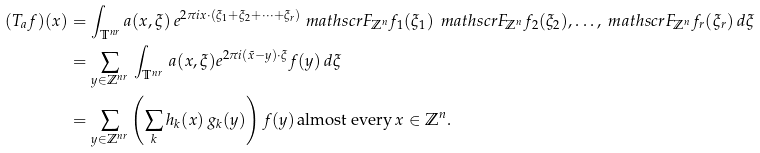Convert formula to latex. <formula><loc_0><loc_0><loc_500><loc_500>( T _ { a } f ) ( x ) & = \int _ { \mathbb { T } ^ { n r } } a ( x , \xi ) \, e ^ { 2 \pi i x \cdot ( \xi _ { 1 } + \xi _ { 2 } + \cdots + \xi _ { r } ) } \ m a t h s c r { F } _ { \mathbb { Z } ^ { n } } f _ { 1 } ( \xi _ { 1 } ) \, \ m a t h s c r { F } _ { \mathbb { Z } ^ { n } } f _ { 2 } ( \xi _ { 2 } ) , \dots , \ m a t h s c r { F } _ { \mathbb { Z } ^ { n } } f _ { r } ( \xi _ { r } ) \, d \xi \\ & = \sum _ { y \in \mathbb { Z } ^ { n r } } \, \int _ { \mathbb { T } ^ { n r } } \, a ( x , \xi ) e ^ { 2 \pi i ( \tilde { x } - y ) \cdot \xi } f ( y ) \, d \xi \\ & = \sum _ { y \in \mathbb { Z } ^ { n r } } \left ( \sum _ { k } h _ { k } ( x ) \, g _ { k } ( y ) \right ) f ( y ) \, \text {almost every} \, x \in \mathbb { Z } ^ { n } .</formula> 